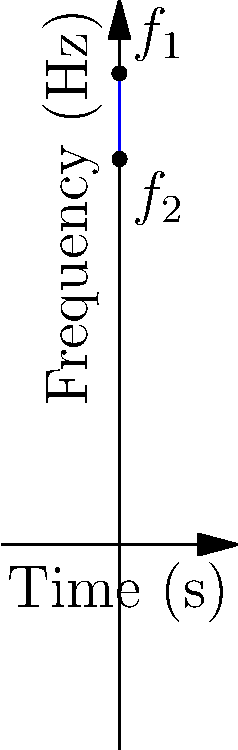In a Doppler ultrasound examination of the brachial artery, you observe a sinusoidal variation in the frequency shift over time, as shown in the graph. The maximum frequency shift is 5500 Hz, and the minimum is 4500 Hz. Given that the ultrasound frequency is 10 MHz and the speed of sound in tissue is 1540 m/s, calculate the peak velocity of blood flow in the artery. To solve this problem, we'll use the Doppler equation and the given information:

1) The Doppler equation: $f_d = \frac{2f_0 v \cos\theta}{c}$

   Where:
   $f_d$ = Doppler shift frequency
   $f_0$ = Transmitted ultrasound frequency
   $v$ = Blood velocity
   $\theta$ = Angle between ultrasound beam and blood flow direction
   $c$ = Speed of sound in tissue

2) We're given:
   $f_0 = 10$ MHz = $10 \times 10^6$ Hz
   $c = 1540$ m/s

3) The maximum Doppler shift is:
   $f_d = 5500 - 4500 = 1000$ Hz

4) Assuming the ultrasound beam is aligned with the blood flow ($\cos\theta = 1$), we can rearrange the Doppler equation to solve for $v$:

   $v = \frac{f_d c}{2f_0}$

5) Substituting the values:

   $v = \frac{1000 \text{ Hz} \times 1540 \text{ m/s}}{2 \times 10 \times 10^6 \text{ Hz}}$

6) Calculate:

   $v = \frac{1540000}{20000000} = 0.077$ m/s

7) Convert to cm/s:

   $v = 0.077 \text{ m/s} \times 100 \text{ cm/m} = 7.7$ cm/s

Therefore, the peak velocity of blood flow in the brachial artery is approximately 7.7 cm/s.
Answer: 7.7 cm/s 